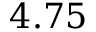Convert formula to latex. <formula><loc_0><loc_0><loc_500><loc_500>4 . 7 5</formula> 